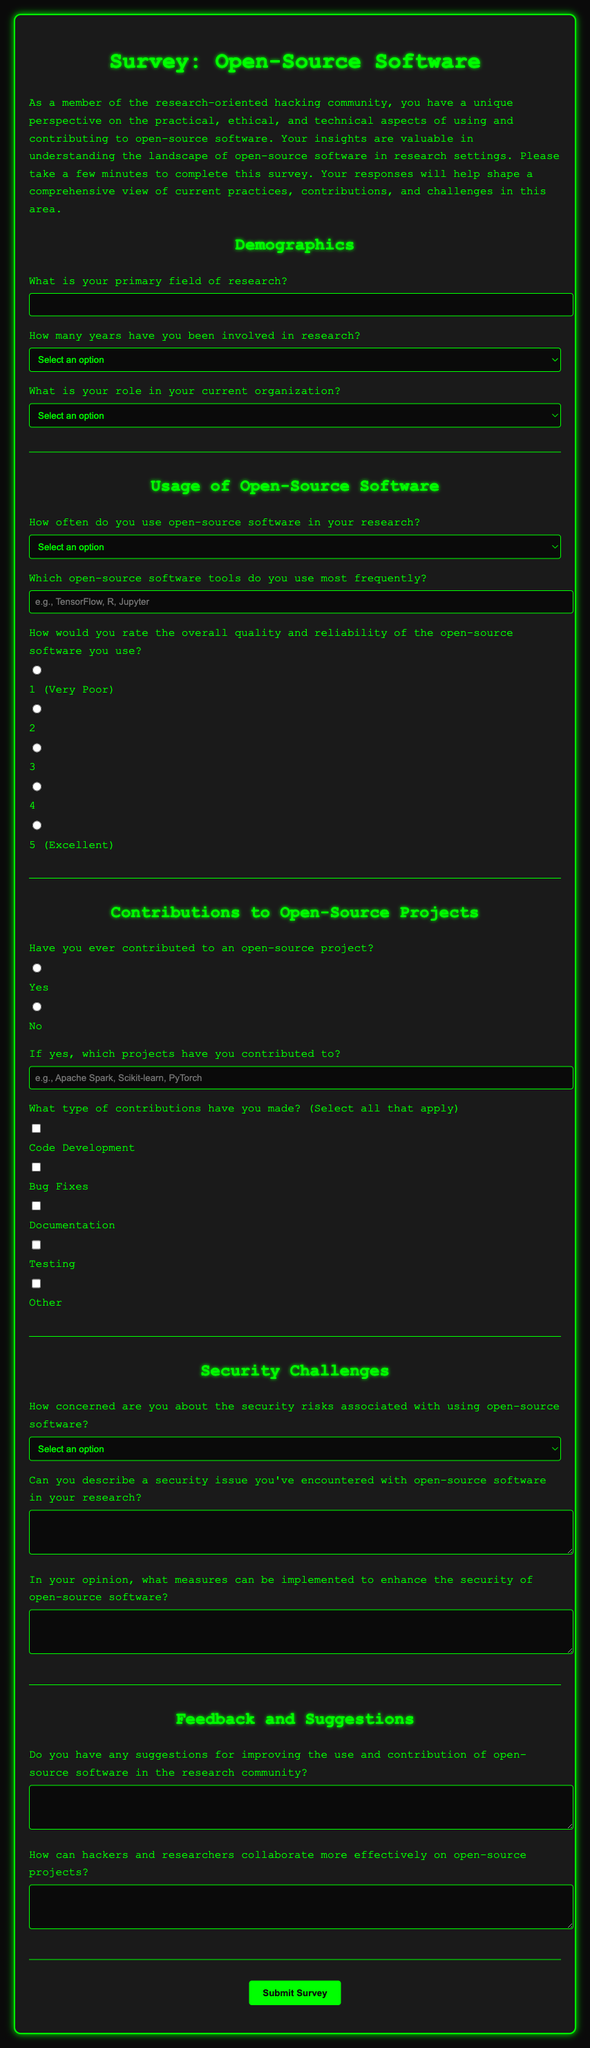What is the title of the survey? The title of the survey is located at the top of the document.
Answer: Open-Source Software Survey How many sections are there in the survey? The survey is divided into multiple sections, each labeled accordingly.
Answer: 5 What is the rating scale for the quality and reliability of open-source software? The survey offers a scale from 1 to 5 to rate the quality and reliability of the software.
Answer: 1 to 5 What type of role options are provided in the Demographics section? The options for roles are specified in a dropdown menu in the document.
Answer: Undergraduate Student, Graduate Student, Postdoc, Research Scientist, Professor, Other How is the concern about security risks assessed? Participants are asked to select from a predefined list of options regarding their level of concern.
Answer: Select an option What type of contributions can participants select from? This question allows multiple selections regarding types of contributions made to open-source projects.
Answer: Code Development, Bug Fixes, Documentation, Testing, Other What is the purpose of the survey as mentioned in the introduction? The purpose is outlined in the introductory paragraph of the survey.
Answer: Understand the landscape of open-source software in research settings How can hackers and researchers collaborate more effectively according to the survey? The response to this question is collected through an open-ended textarea in the survey.
Answer: Open-ended response What feedback type is requested towards the end of the survey? The survey solicits suggestions for improvement in the usage and contribution of open-source software.
Answer: Suggestions for improving usage and contribution 